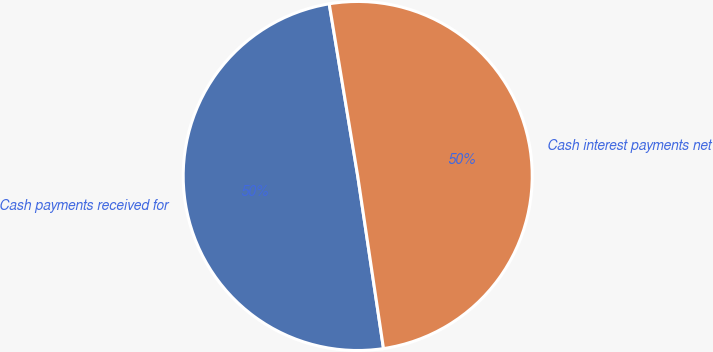Convert chart to OTSL. <chart><loc_0><loc_0><loc_500><loc_500><pie_chart><fcel>Cash payments received for<fcel>Cash interest payments net<nl><fcel>49.75%<fcel>50.25%<nl></chart> 